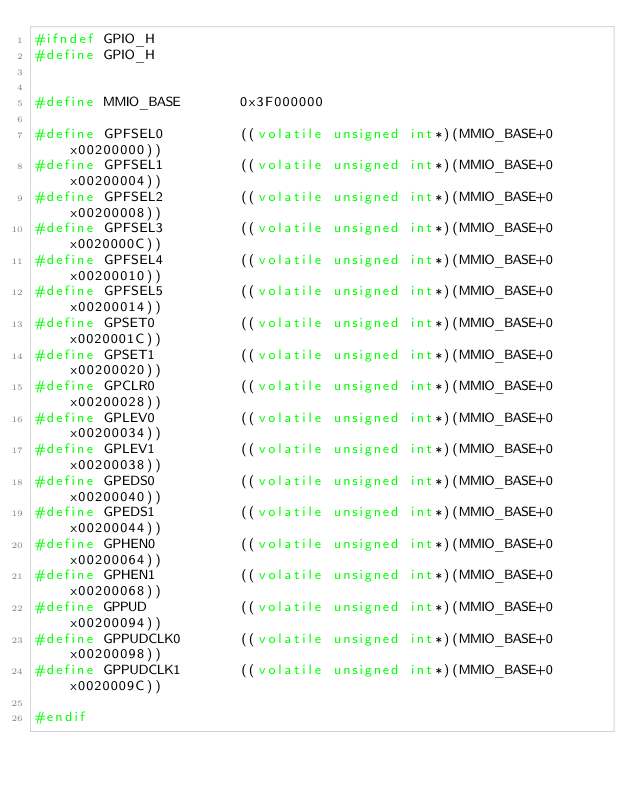Convert code to text. <code><loc_0><loc_0><loc_500><loc_500><_C_>#ifndef GPIO_H
#define GPIO_H


#define MMIO_BASE       0x3F000000

#define GPFSEL0         ((volatile unsigned int*)(MMIO_BASE+0x00200000))
#define GPFSEL1         ((volatile unsigned int*)(MMIO_BASE+0x00200004))
#define GPFSEL2         ((volatile unsigned int*)(MMIO_BASE+0x00200008))
#define GPFSEL3         ((volatile unsigned int*)(MMIO_BASE+0x0020000C))
#define GPFSEL4         ((volatile unsigned int*)(MMIO_BASE+0x00200010))
#define GPFSEL5         ((volatile unsigned int*)(MMIO_BASE+0x00200014))
#define GPSET0          ((volatile unsigned int*)(MMIO_BASE+0x0020001C))
#define GPSET1          ((volatile unsigned int*)(MMIO_BASE+0x00200020))
#define GPCLR0          ((volatile unsigned int*)(MMIO_BASE+0x00200028))
#define GPLEV0          ((volatile unsigned int*)(MMIO_BASE+0x00200034))
#define GPLEV1          ((volatile unsigned int*)(MMIO_BASE+0x00200038))
#define GPEDS0          ((volatile unsigned int*)(MMIO_BASE+0x00200040))
#define GPEDS1          ((volatile unsigned int*)(MMIO_BASE+0x00200044))
#define GPHEN0          ((volatile unsigned int*)(MMIO_BASE+0x00200064))
#define GPHEN1          ((volatile unsigned int*)(MMIO_BASE+0x00200068))
#define GPPUD           ((volatile unsigned int*)(MMIO_BASE+0x00200094))
#define GPPUDCLK0       ((volatile unsigned int*)(MMIO_BASE+0x00200098))
#define GPPUDCLK1       ((volatile unsigned int*)(MMIO_BASE+0x0020009C))

#endif
</code> 